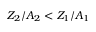<formula> <loc_0><loc_0><loc_500><loc_500>Z _ { 2 } / A _ { 2 } < Z _ { 1 } / A _ { 1 }</formula> 